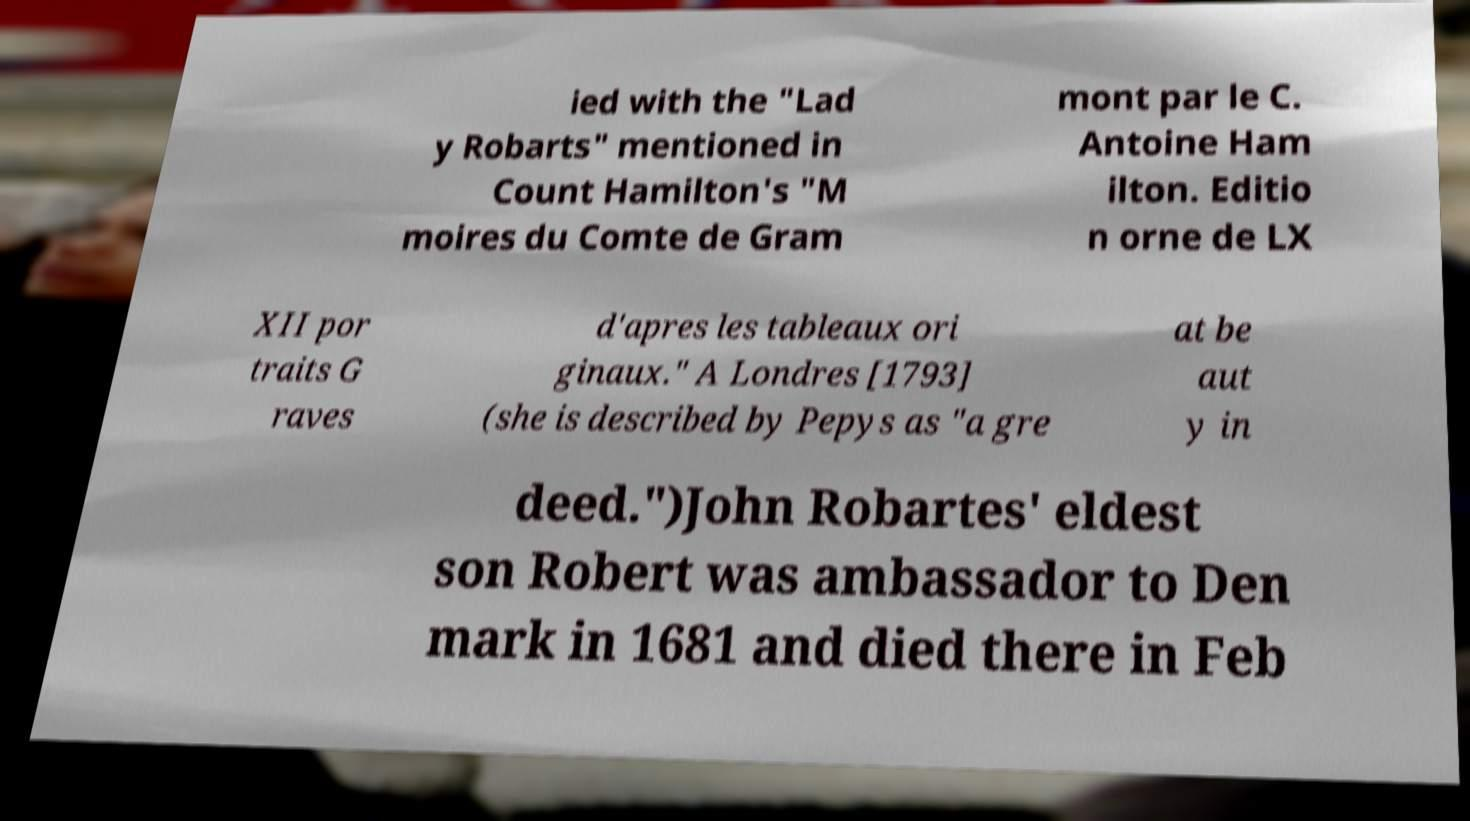Could you assist in decoding the text presented in this image and type it out clearly? ied with the "Lad y Robarts" mentioned in Count Hamilton's "M moires du Comte de Gram mont par le C. Antoine Ham ilton. Editio n orne de LX XII por traits G raves d'apres les tableaux ori ginaux." A Londres [1793] (she is described by Pepys as "a gre at be aut y in deed.")John Robartes' eldest son Robert was ambassador to Den mark in 1681 and died there in Feb 